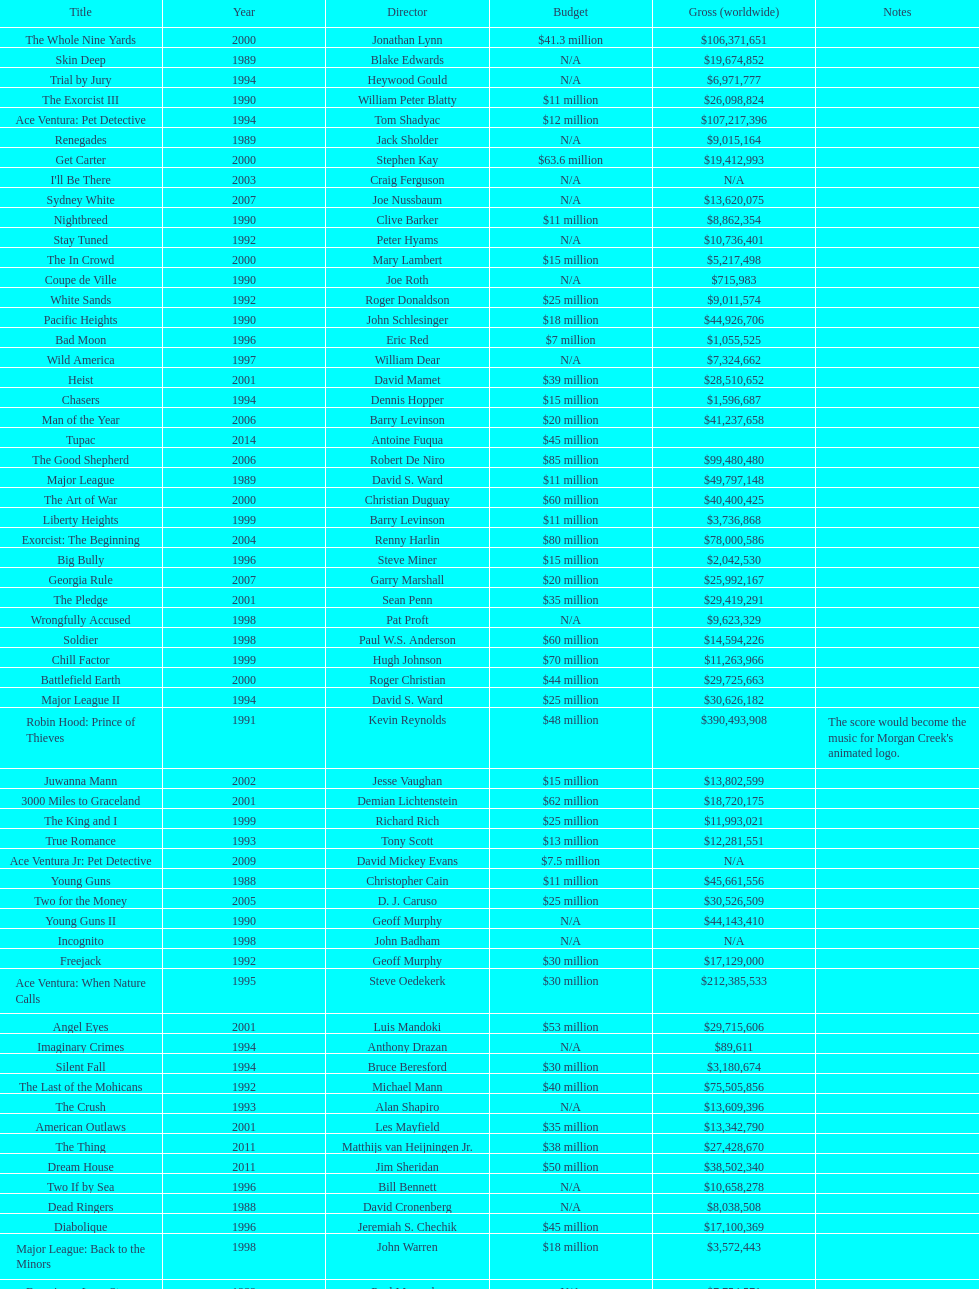Write the full table. {'header': ['Title', 'Year', 'Director', 'Budget', 'Gross (worldwide)', 'Notes'], 'rows': [['The Whole Nine Yards', '2000', 'Jonathan Lynn', '$41.3 million', '$106,371,651', ''], ['Skin Deep', '1989', 'Blake Edwards', 'N/A', '$19,674,852', ''], ['Trial by Jury', '1994', 'Heywood Gould', 'N/A', '$6,971,777', ''], ['The Exorcist III', '1990', 'William Peter Blatty', '$11 million', '$26,098,824', ''], ['Ace Ventura: Pet Detective', '1994', 'Tom Shadyac', '$12 million', '$107,217,396', ''], ['Renegades', '1989', 'Jack Sholder', 'N/A', '$9,015,164', ''], ['Get Carter', '2000', 'Stephen Kay', '$63.6 million', '$19,412,993', ''], ["I'll Be There", '2003', 'Craig Ferguson', 'N/A', 'N/A', ''], ['Sydney White', '2007', 'Joe Nussbaum', 'N/A', '$13,620,075', ''], ['Nightbreed', '1990', 'Clive Barker', '$11 million', '$8,862,354', ''], ['Stay Tuned', '1992', 'Peter Hyams', 'N/A', '$10,736,401', ''], ['The In Crowd', '2000', 'Mary Lambert', '$15 million', '$5,217,498', ''], ['Coupe de Ville', '1990', 'Joe Roth', 'N/A', '$715,983', ''], ['White Sands', '1992', 'Roger Donaldson', '$25 million', '$9,011,574', ''], ['Pacific Heights', '1990', 'John Schlesinger', '$18 million', '$44,926,706', ''], ['Bad Moon', '1996', 'Eric Red', '$7 million', '$1,055,525', ''], ['Wild America', '1997', 'William Dear', 'N/A', '$7,324,662', ''], ['Heist', '2001', 'David Mamet', '$39 million', '$28,510,652', ''], ['Chasers', '1994', 'Dennis Hopper', '$15 million', '$1,596,687', ''], ['Man of the Year', '2006', 'Barry Levinson', '$20 million', '$41,237,658', ''], ['Tupac', '2014', 'Antoine Fuqua', '$45 million', '', ''], ['The Good Shepherd', '2006', 'Robert De Niro', '$85 million', '$99,480,480', ''], ['Major League', '1989', 'David S. Ward', '$11 million', '$49,797,148', ''], ['The Art of War', '2000', 'Christian Duguay', '$60 million', '$40,400,425', ''], ['Liberty Heights', '1999', 'Barry Levinson', '$11 million', '$3,736,868', ''], ['Exorcist: The Beginning', '2004', 'Renny Harlin', '$80 million', '$78,000,586', ''], ['Big Bully', '1996', 'Steve Miner', '$15 million', '$2,042,530', ''], ['Georgia Rule', '2007', 'Garry Marshall', '$20 million', '$25,992,167', ''], ['The Pledge', '2001', 'Sean Penn', '$35 million', '$29,419,291', ''], ['Wrongfully Accused', '1998', 'Pat Proft', 'N/A', '$9,623,329', ''], ['Soldier', '1998', 'Paul W.S. Anderson', '$60 million', '$14,594,226', ''], ['Chill Factor', '1999', 'Hugh Johnson', '$70 million', '$11,263,966', ''], ['Battlefield Earth', '2000', 'Roger Christian', '$44 million', '$29,725,663', ''], ['Major League II', '1994', 'David S. Ward', '$25 million', '$30,626,182', ''], ['Robin Hood: Prince of Thieves', '1991', 'Kevin Reynolds', '$48 million', '$390,493,908', "The score would become the music for Morgan Creek's animated logo."], ['Juwanna Mann', '2002', 'Jesse Vaughan', '$15 million', '$13,802,599', ''], ['3000 Miles to Graceland', '2001', 'Demian Lichtenstein', '$62 million', '$18,720,175', ''], ['The King and I', '1999', 'Richard Rich', '$25 million', '$11,993,021', ''], ['True Romance', '1993', 'Tony Scott', '$13 million', '$12,281,551', ''], ['Ace Ventura Jr: Pet Detective', '2009', 'David Mickey Evans', '$7.5 million', 'N/A', ''], ['Young Guns', '1988', 'Christopher Cain', '$11 million', '$45,661,556', ''], ['Two for the Money', '2005', 'D. J. Caruso', '$25 million', '$30,526,509', ''], ['Young Guns II', '1990', 'Geoff Murphy', 'N/A', '$44,143,410', ''], ['Incognito', '1998', 'John Badham', 'N/A', 'N/A', ''], ['Freejack', '1992', 'Geoff Murphy', '$30 million', '$17,129,000', ''], ['Ace Ventura: When Nature Calls', '1995', 'Steve Oedekerk', '$30 million', '$212,385,533', ''], ['Angel Eyes', '2001', 'Luis Mandoki', '$53 million', '$29,715,606', ''], ['Imaginary Crimes', '1994', 'Anthony Drazan', 'N/A', '$89,611', ''], ['Silent Fall', '1994', 'Bruce Beresford', '$30 million', '$3,180,674', ''], ['The Last of the Mohicans', '1992', 'Michael Mann', '$40 million', '$75,505,856', ''], ['The Crush', '1993', 'Alan Shapiro', 'N/A', '$13,609,396', ''], ['American Outlaws', '2001', 'Les Mayfield', '$35 million', '$13,342,790', ''], ['The Thing', '2011', 'Matthijs van Heijningen Jr.', '$38 million', '$27,428,670', ''], ['Dream House', '2011', 'Jim Sheridan', '$50 million', '$38,502,340', ''], ['Two If by Sea', '1996', 'Bill Bennett', 'N/A', '$10,658,278', ''], ['Dead Ringers', '1988', 'David Cronenberg', 'N/A', '$8,038,508', ''], ['Diabolique', '1996', 'Jeremiah S. Chechik', '$45 million', '$17,100,369', ''], ['Major League: Back to the Minors', '1998', 'John Warren', '$18 million', '$3,572,443', ''], ['Enemies, a Love Story', '1989', 'Paul Mazursky', 'N/A', '$7,754,571', ''], ['Dominion: Prequel to the Exorcist', '2005', 'Paul Schrader', '$30 million', '$251,495', '']]} What movie was made immediately before the pledge? The In Crowd. 